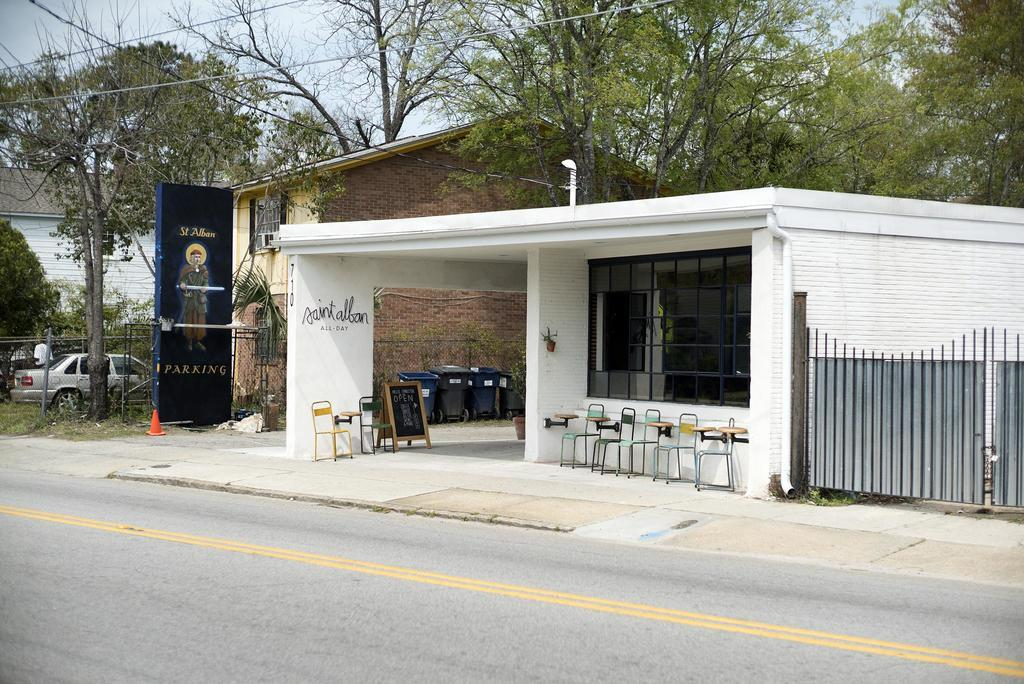What type of establishment is shown in the image? There is a restaurant in the image. Where is the restaurant situated? The restaurant is located by the side of the road. What can be seen in the background of the image? There are trees visible in the background of the image. Can you see a farmer working in the image? There is no farmer present in the image. What type of transportation can be seen using a match to ignite its engine in the image? There is no transportation or use of matches present in the image. 